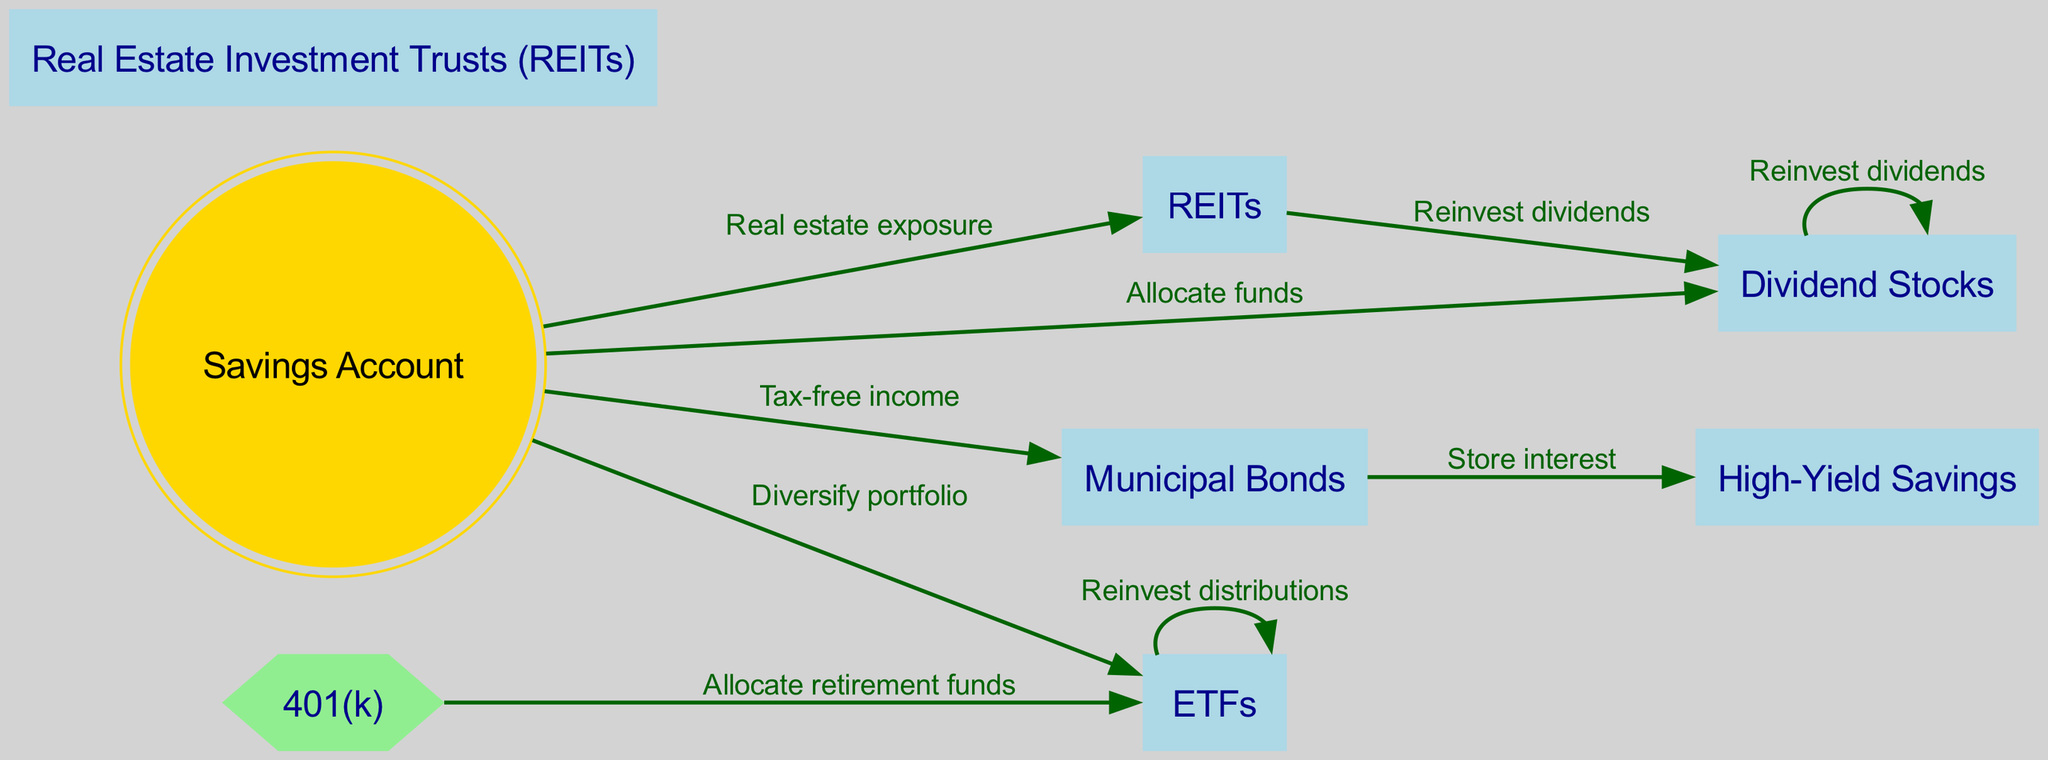What is the starting point for investing in Dividend Stocks? The starting point is the "Savings Account," where funds are allocated to Dividend Stocks.
Answer: Savings Account How many nodes are present in the diagram? By counting each distinct type of investment in the "nodes" section, we find there are a total of seven nodes.
Answer: 7 Which asset is directly linked to High-Yield Savings? High-Yield Savings is directly linked through "Store interest" from "Municipal Bonds."
Answer: Municipal Bonds What is the relationship between ETFs and Dividend Stocks? "ETFs" can receive reinvested distributions back into themselves, while "REITs" also have a link that allows dividends to be reinvested into "Dividend Stocks."
Answer: Reinvest dividends Which node has a double circle shape? The "Savings Account" is represented with a double circle shape, indicating its importance in this investment allocation diagram.
Answer: Savings Account If I allocate retirement funds from my 401(k), where would I invest? The "401(k)" directs funds to "ETFs," indicating this as the specific investment option for retirement allocation.
Answer: ETFs Which investments allow for reinvestment of dividends? Both "Dividend Stocks" and "ETFs" allow reinvestment of dividends, forming a loop back to themselves; additionally, "REITs" also reinvest into "Dividend Stocks."
Answer: Dividend Stocks, ETFs, REITs How many edges connect to the Savings Account? There are four edges connecting to the "Savings Account," showing various allocation paths to Dividend Stocks, ETFs, Municipal Bonds, and REITs.
Answer: 4 What is the purpose of allocating funds to Municipal Bonds? Allocating funds to Municipal Bonds is aimed at generating tax-free income to benefit the investor financially.
Answer: Tax-free income 